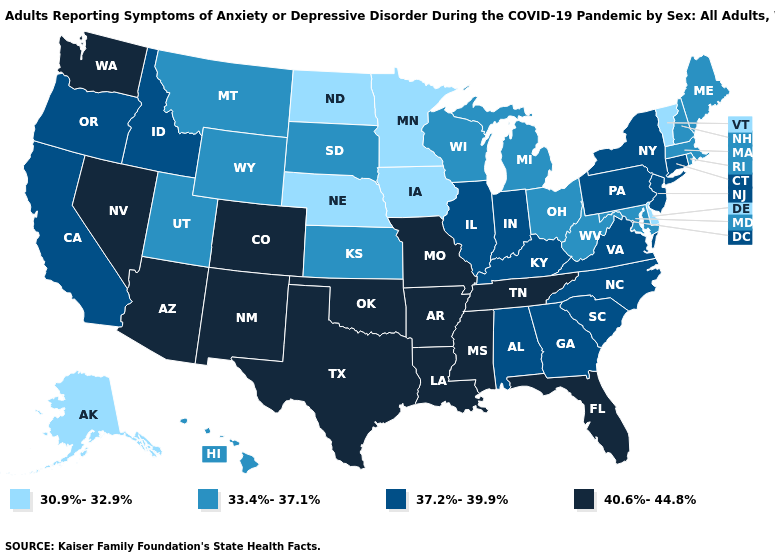Does Maryland have the lowest value in the USA?
Keep it brief. No. What is the value of Florida?
Short answer required. 40.6%-44.8%. Among the states that border Nevada , does California have the lowest value?
Write a very short answer. No. Does Massachusetts have the same value as New Mexico?
Be succinct. No. Name the states that have a value in the range 33.4%-37.1%?
Write a very short answer. Hawaii, Kansas, Maine, Maryland, Massachusetts, Michigan, Montana, New Hampshire, Ohio, Rhode Island, South Dakota, Utah, West Virginia, Wisconsin, Wyoming. What is the value of Missouri?
Concise answer only. 40.6%-44.8%. What is the lowest value in states that border Arkansas?
Write a very short answer. 40.6%-44.8%. Name the states that have a value in the range 40.6%-44.8%?
Quick response, please. Arizona, Arkansas, Colorado, Florida, Louisiana, Mississippi, Missouri, Nevada, New Mexico, Oklahoma, Tennessee, Texas, Washington. Does Utah have a higher value than Delaware?
Answer briefly. Yes. What is the value of Arizona?
Answer briefly. 40.6%-44.8%. Which states have the lowest value in the USA?
Answer briefly. Alaska, Delaware, Iowa, Minnesota, Nebraska, North Dakota, Vermont. Does New York have the highest value in the USA?
Give a very brief answer. No. What is the value of Nevada?
Give a very brief answer. 40.6%-44.8%. Among the states that border West Virginia , does Ohio have the lowest value?
Answer briefly. Yes. Does Arizona have the highest value in the West?
Write a very short answer. Yes. 